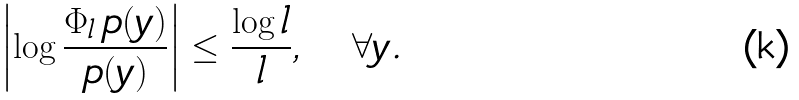Convert formula to latex. <formula><loc_0><loc_0><loc_500><loc_500>\left | \log \frac { \Phi _ { l } \, p ( y ) } { p ( y ) } \right | \leq \frac { \log l } { l } , \quad \forall y .</formula> 